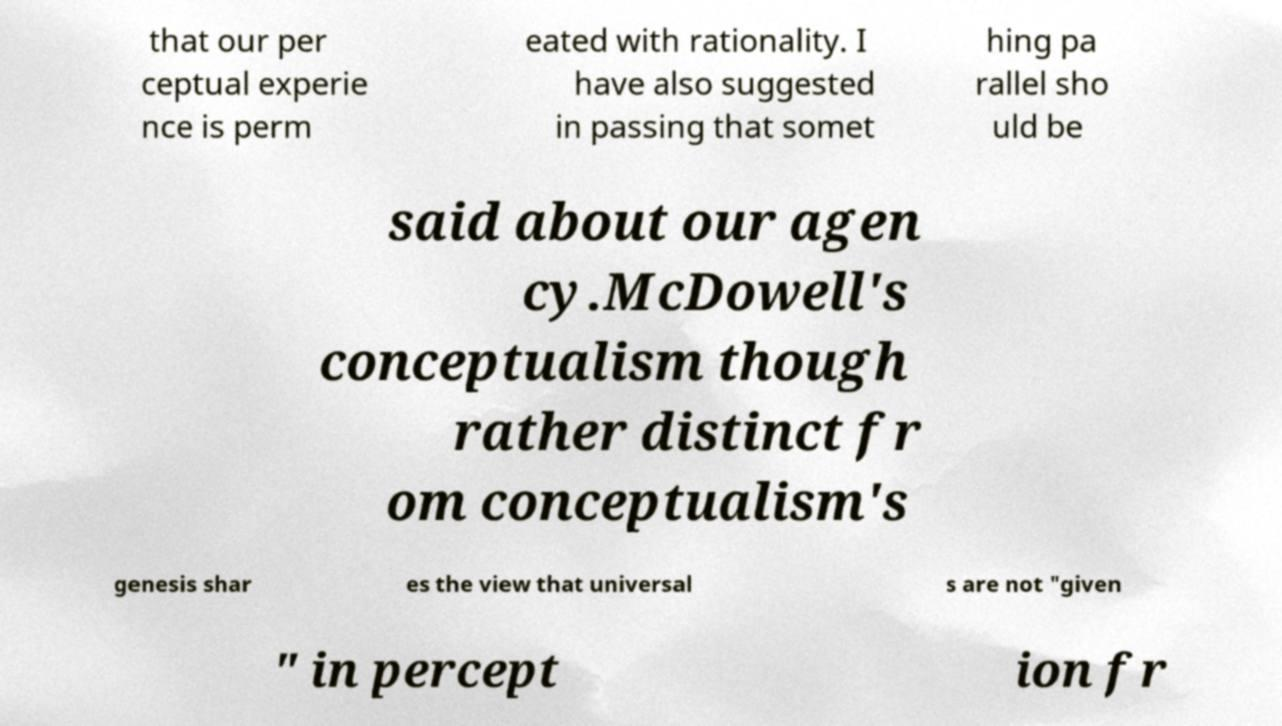Please read and relay the text visible in this image. What does it say? that our per ceptual experie nce is perm eated with rationality. I have also suggested in passing that somet hing pa rallel sho uld be said about our agen cy.McDowell's conceptualism though rather distinct fr om conceptualism's genesis shar es the view that universal s are not "given " in percept ion fr 